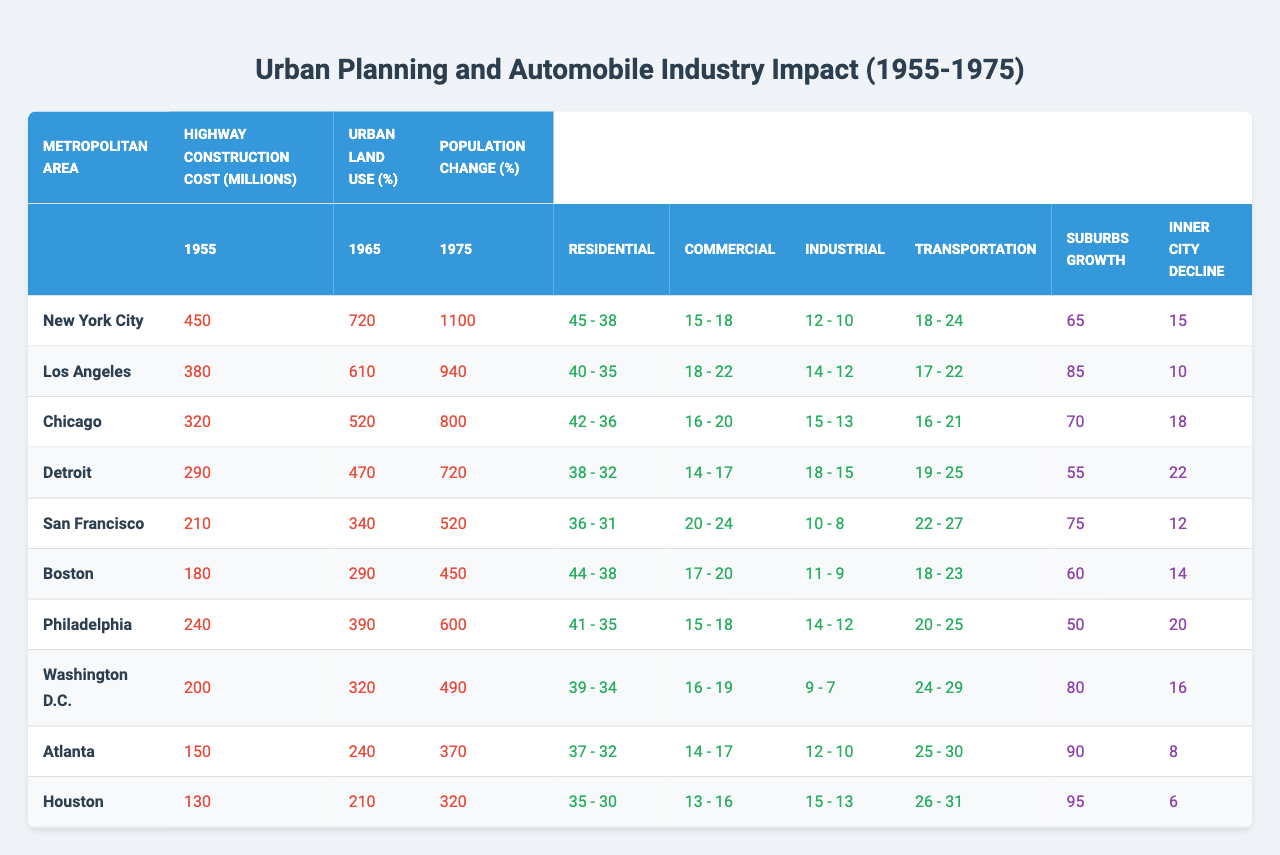What was the highway construction cost of New York City in 1975? Referring to the table, the highway construction cost for New York City in 1975 is listed as 1,100 million.
Answer: 1,100 million Which metropolitan area had the highest percentage of residential land use in 1955? Looking at the table, New York City had the highest percentage of residential land use at 45% in 1955.
Answer: New York City What was the percentage decline in residential land use in Los Angeles from 1955 to 1975? For Los Angeles, the residential land use dropped from 40% in 1955 to 35% in 1975, which is a decline of 5%.
Answer: 5% True or False: The inner city population decline in Chicago was larger than in Los Angeles between 1955 and 1975. Chicago's inner city population decline was 18%, while Los Angeles's was 10%, confirming that Chicago's decline was larger.
Answer: True Which metropolitan area experienced the least growth in suburbs from 1955 to 1975? The table shows Houston had a suburbs population growth of 90%, which is the least compared to other areas such as Atlanta (95%) and Detroit (55%).
Answer: Detroit What is the total highway construction cost for all metropolitan areas combined in 1965? By summing the highway construction costs in 1965 for each area: 720 + 610 + 520 + 470 + 340 + 290 + 390 + 320 + 240 + 210 = 4,350 million.
Answer: 4,350 million What was the overall percentage change in transportation land use in San Francisco from 1955 to 1975? The transportation land use changed from 22% in 1955 to 27% in 1975, which is an increase of 5%.
Answer: 5% Based on the table, how did commercial land use in Detroit change from 1955 to 1975? In 1955, commercial land use in Detroit was 14%, and in 1975 it increased to 17%, indicating a growth of 3%.
Answer: Increased by 3% Which two metropolitan areas had the highest increase in transportation land use from 1955 to 1975? The increases for transportation land use were: New York City (from 18% to 24% = 6%) and Detroit (from 19% to 25% = 6%), making both the highest.
Answer: New York City and Detroit What is the average inner city population decline percentage among the metropolitan areas listed? Calculate the inner city population decline: (15 + 10 + 18 + 22 + 12 + 14 + 20 + 16 + 8 + 6) / 10 = 13.1%.
Answer: 13.1% What was the trend in industrial land use in Boston between 1955 and 1975? Industrial land use in Boston decreased from 11% in 1955 to 9% in 1975, indicating a downward trend of 2%.
Answer: Decrease of 2% 